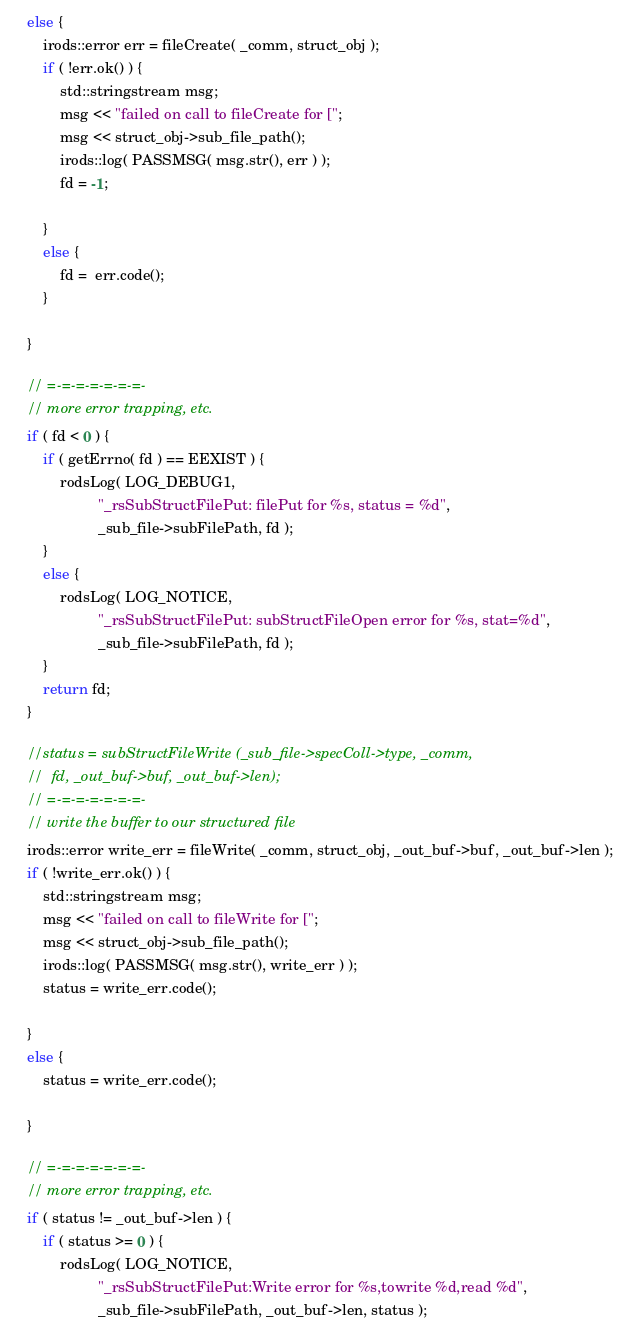Convert code to text. <code><loc_0><loc_0><loc_500><loc_500><_C++_>    else {
        irods::error err = fileCreate( _comm, struct_obj );
        if ( !err.ok() ) {
            std::stringstream msg;
            msg << "failed on call to fileCreate for [";
            msg << struct_obj->sub_file_path();
            irods::log( PASSMSG( msg.str(), err ) );
            fd = -1;

        }
        else {
            fd =  err.code();
        }

    }

    // =-=-=-=-=-=-=-
    // more error trapping, etc.
    if ( fd < 0 ) {
        if ( getErrno( fd ) == EEXIST ) {
            rodsLog( LOG_DEBUG1,
                     "_rsSubStructFilePut: filePut for %s, status = %d",
                     _sub_file->subFilePath, fd );
        }
        else {
            rodsLog( LOG_NOTICE,
                     "_rsSubStructFilePut: subStructFileOpen error for %s, stat=%d",
                     _sub_file->subFilePath, fd );
        }
        return fd;
    }

    //status = subStructFileWrite (_sub_file->specColl->type, _comm,
    //  fd, _out_buf->buf, _out_buf->len);
    // =-=-=-=-=-=-=-
    // write the buffer to our structured file
    irods::error write_err = fileWrite( _comm, struct_obj, _out_buf->buf, _out_buf->len );
    if ( !write_err.ok() ) {
        std::stringstream msg;
        msg << "failed on call to fileWrite for [";
        msg << struct_obj->sub_file_path();
        irods::log( PASSMSG( msg.str(), write_err ) );
        status = write_err.code();

    }
    else {
        status = write_err.code();

    }

    // =-=-=-=-=-=-=-
    // more error trapping, etc.
    if ( status != _out_buf->len ) {
        if ( status >= 0 ) {
            rodsLog( LOG_NOTICE,
                     "_rsSubStructFilePut:Write error for %s,towrite %d,read %d",
                     _sub_file->subFilePath, _out_buf->len, status );</code> 